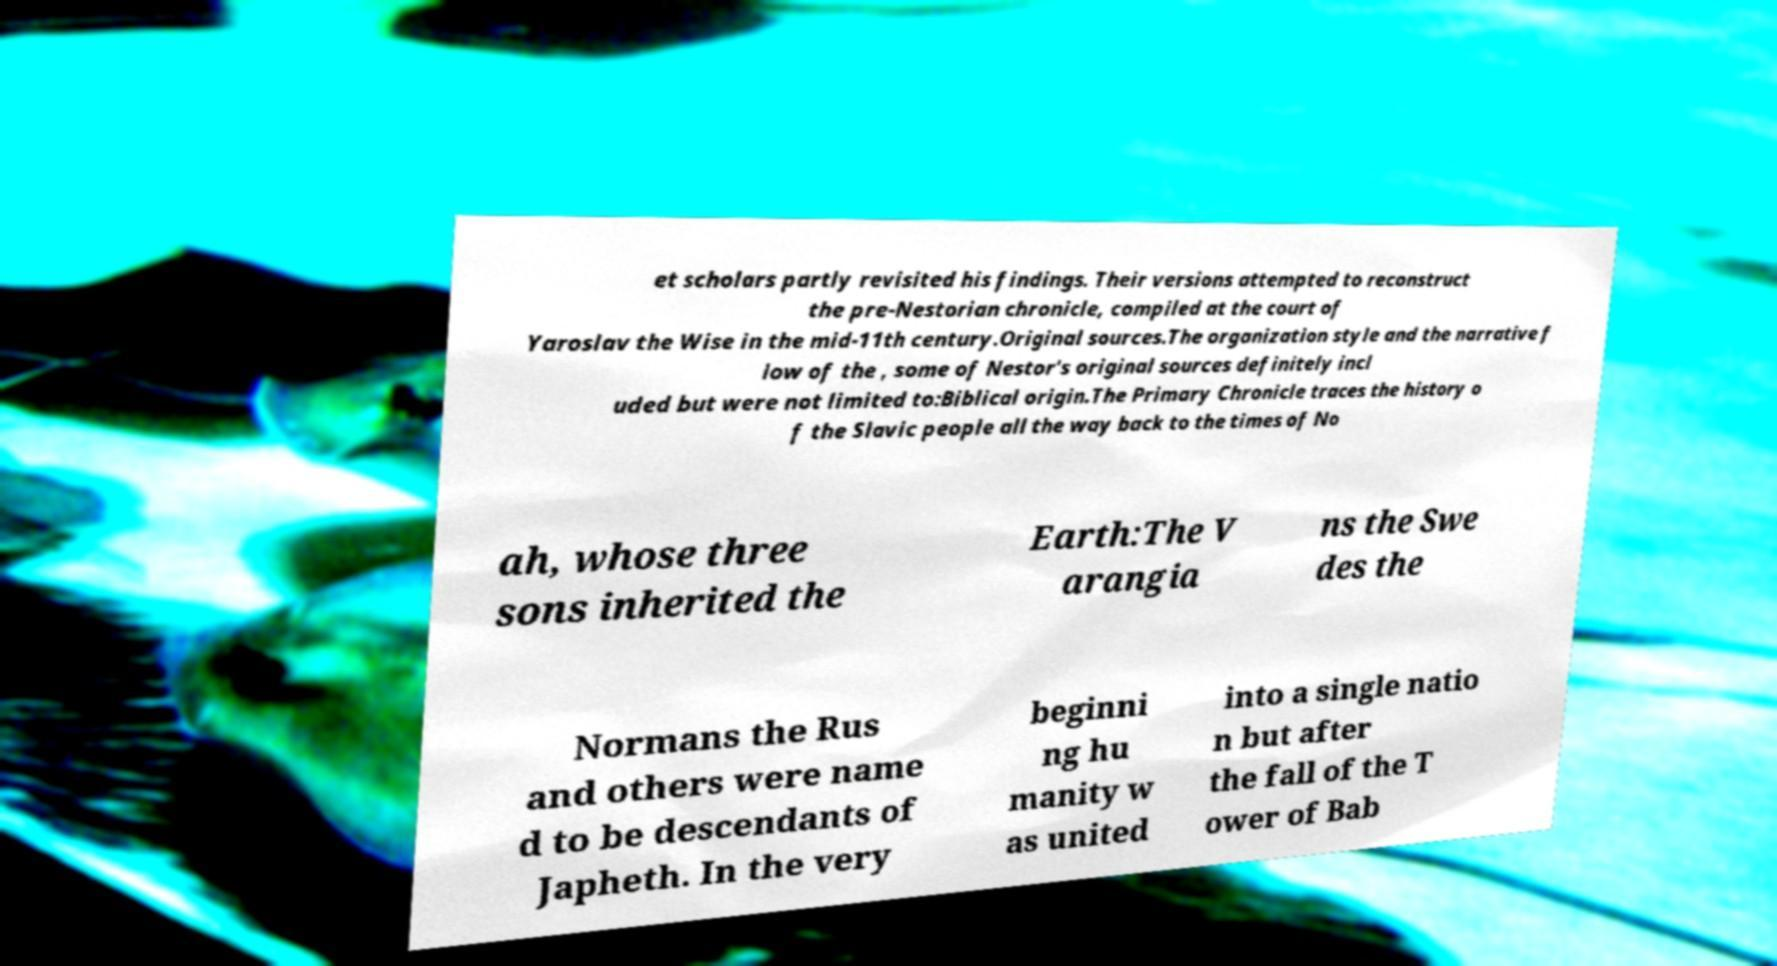There's text embedded in this image that I need extracted. Can you transcribe it verbatim? et scholars partly revisited his findings. Their versions attempted to reconstruct the pre-Nestorian chronicle, compiled at the court of Yaroslav the Wise in the mid-11th century.Original sources.The organization style and the narrative f low of the , some of Nestor's original sources definitely incl uded but were not limited to:Biblical origin.The Primary Chronicle traces the history o f the Slavic people all the way back to the times of No ah, whose three sons inherited the Earth:The V arangia ns the Swe des the Normans the Rus and others were name d to be descendants of Japheth. In the very beginni ng hu manity w as united into a single natio n but after the fall of the T ower of Bab 